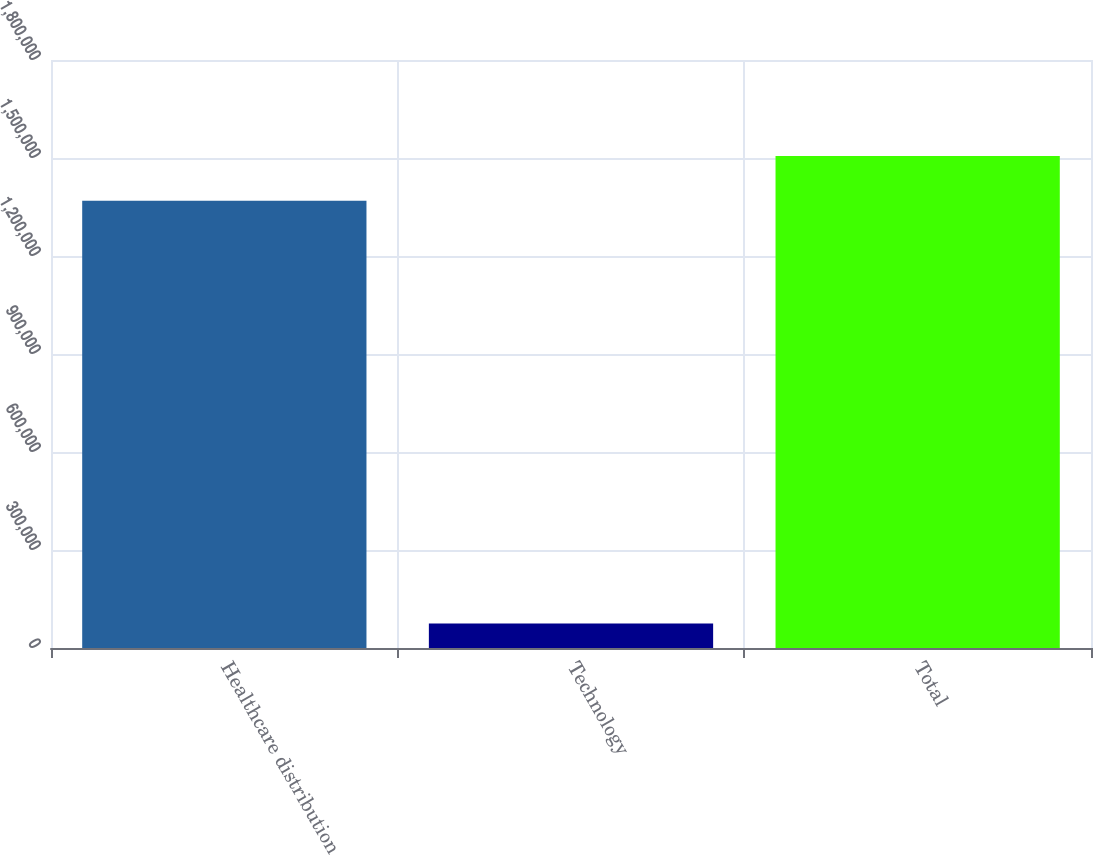Convert chart. <chart><loc_0><loc_0><loc_500><loc_500><bar_chart><fcel>Healthcare distribution<fcel>Technology<fcel>Total<nl><fcel>1.36924e+06<fcel>75030<fcel>1.50617e+06<nl></chart> 